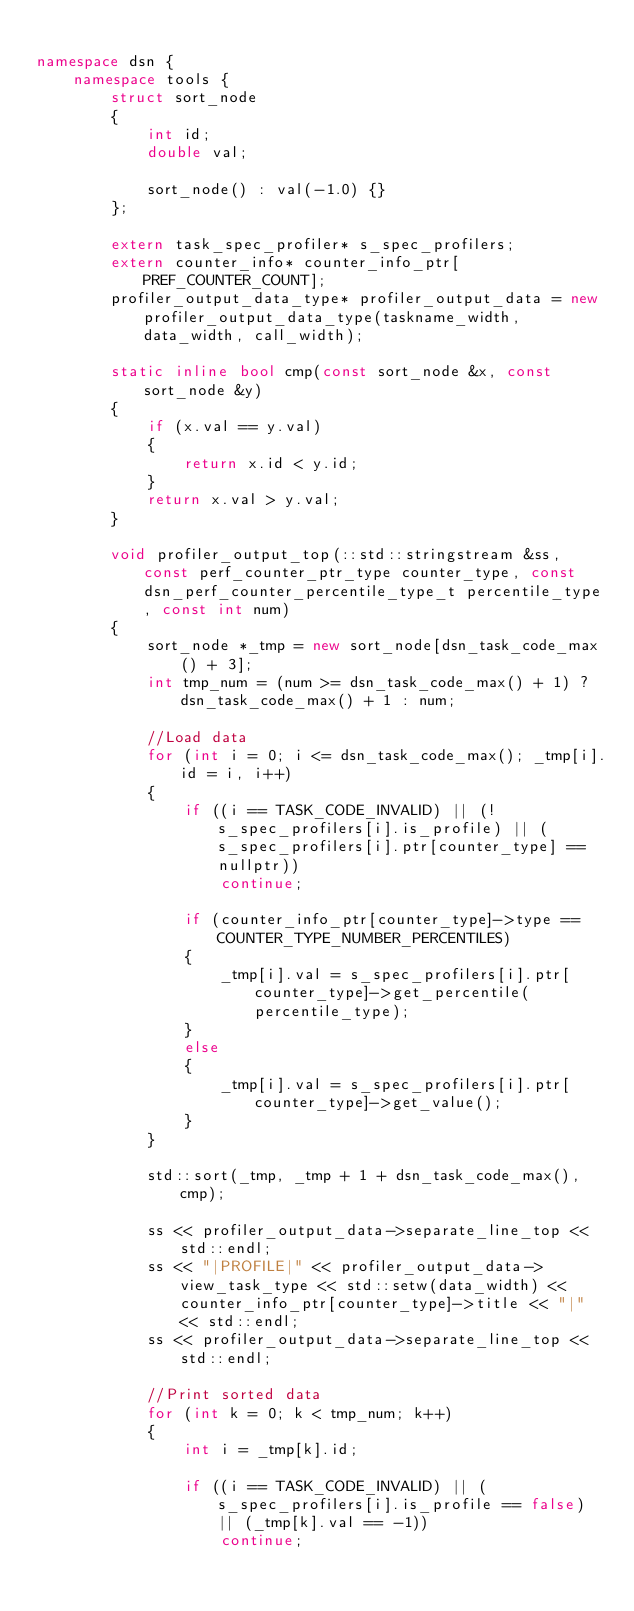Convert code to text. <code><loc_0><loc_0><loc_500><loc_500><_C++_>
namespace dsn {
    namespace tools {
        struct sort_node
        {
            int id;
            double val;

            sort_node() : val(-1.0) {}
        };

        extern task_spec_profiler* s_spec_profilers;
        extern counter_info* counter_info_ptr[PREF_COUNTER_COUNT];
        profiler_output_data_type* profiler_output_data = new profiler_output_data_type(taskname_width, data_width, call_width);

        static inline bool cmp(const sort_node &x, const sort_node &y)
        {
            if (x.val == y.val)
            {
                return x.id < y.id;
            }
            return x.val > y.val;
        }

        void profiler_output_top(::std::stringstream &ss, const perf_counter_ptr_type counter_type, const dsn_perf_counter_percentile_type_t percentile_type, const int num)
        {
            sort_node *_tmp = new sort_node[dsn_task_code_max() + 3];
            int tmp_num = (num >= dsn_task_code_max() + 1) ? dsn_task_code_max() + 1 : num;

            //Load data
            for (int i = 0; i <= dsn_task_code_max(); _tmp[i].id = i, i++)
            {
                if ((i == TASK_CODE_INVALID) || (!s_spec_profilers[i].is_profile) || (s_spec_profilers[i].ptr[counter_type] == nullptr))
                    continue;

                if (counter_info_ptr[counter_type]->type == COUNTER_TYPE_NUMBER_PERCENTILES)
                {
                    _tmp[i].val = s_spec_profilers[i].ptr[counter_type]->get_percentile(percentile_type);
                }
                else
                {
                    _tmp[i].val = s_spec_profilers[i].ptr[counter_type]->get_value();
                }
            }

            std::sort(_tmp, _tmp + 1 + dsn_task_code_max(), cmp);

            ss << profiler_output_data->separate_line_top << std::endl;
            ss << "|PROFILE|" << profiler_output_data->view_task_type << std::setw(data_width) << counter_info_ptr[counter_type]->title << "|" << std::endl;
            ss << profiler_output_data->separate_line_top << std::endl;

            //Print sorted data
            for (int k = 0; k < tmp_num; k++)
            {
                int i = _tmp[k].id;

                if ((i == TASK_CODE_INVALID) || (s_spec_profilers[i].is_profile == false) || (_tmp[k].val == -1))
                    continue;
</code> 